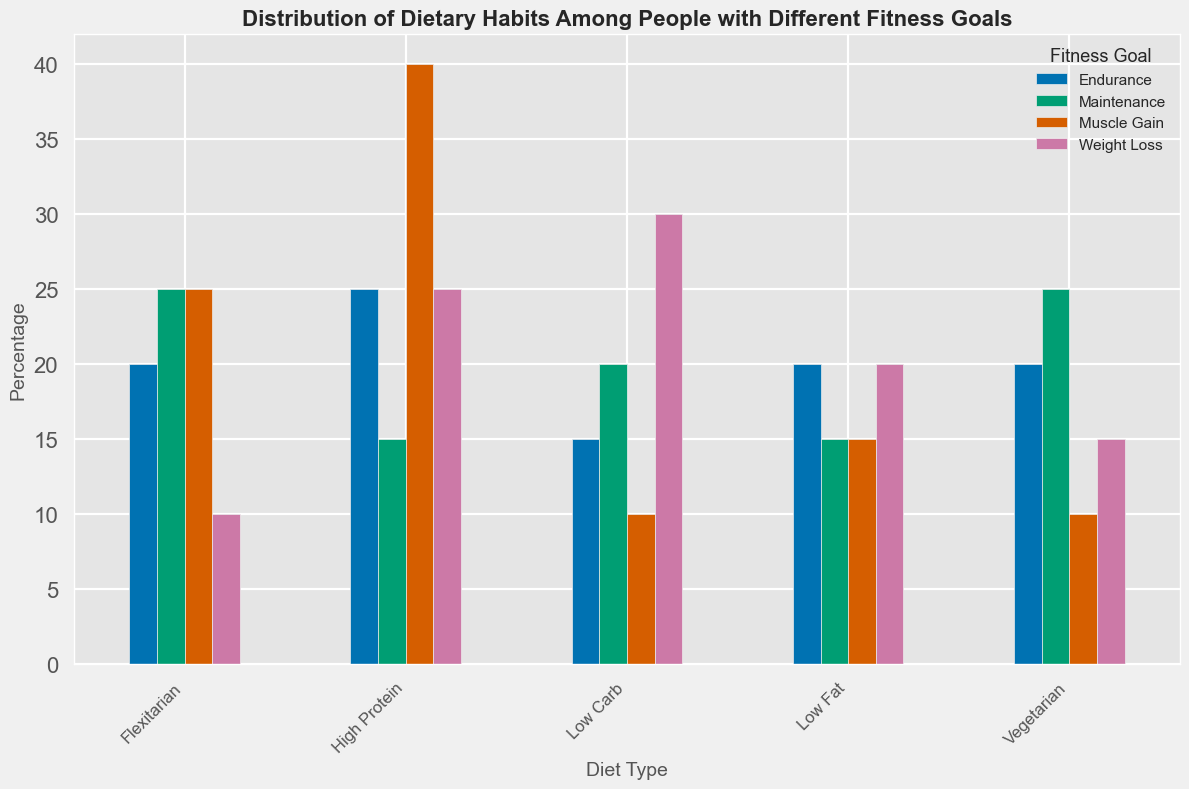What is the most common diet type among people aiming for muscle gain? By examining the height of the bars for each diet type under the "Muscle Gain" category, the "High Protein" bar is the tallest.
Answer: High Protein Which fitness goal has the highest proportion of people following a low-carb diet? Check the heights of the "Low Carb" bars for each fitness goal. The "Weight Loss" bar is the tallest.
Answer: Weight Loss How does the percentage of people following a vegetarian diet for muscle gain compare to those for weight loss? Compare the heights of the "Vegetarian" bars for "Muscle Gain" and "Weight Loss". The bar for "Weight Loss" is taller (15% vs. 10%).
Answer: Weight Loss has a higher percentage What is the average percentage of people following a low-fat diet across all fitness goals? Sum the percentages for "Low Fat" across all fitness goals (20% + 15% + 20% + 15%) = 70%, then divide by 4 (70/4).
Answer: 17.5% For which fitness goal is the Flexitarian diet as popular as the most common diet type for that goal? Check the bars for each goal and identify the most common diet. Compare this to the Flexitarian bar to see where they match. For "Maintenance", Flexitarian (25%) is equal to Vegetarian (25%), which is the most common.
Answer: Maintenance Among the "High Protein" diet followers, which fitness goal has the lowest percentage? Examine the bars for "High Protein" and identify the shortest one. It's "Maintenance" (15%).
Answer: Maintenance What is the combined percentage of people following either a low-carb or high-protein diet for weight loss? Add the percentages for "Low Carb" (30%) and "High Protein" (25%) for "Weight Loss". The total is 30 + 25 = 55%.
Answer: 55% Which diet type shows an equal distribution (percentages) among all fitness goals? Compare the bars horizontally for each diet type. The "Flexitarian" diet has bars of the same height (20%) across all fitness goals.
Answer: Flexitarian What is the difference in percentage between people following a high-protein diet for muscle gain and those for endurance? Subtract the percentage of "Endurance" (25%) from "Muscle Gain" (40%) for "High Protein". 40-25=15%.
Answer: 15% Which diet type is least popular for both weight loss and muscle gain combined? Compare combined percentages of all diet types for "Weight Loss" and "Muscle Gain". "Vegetarian" has 15% (Weight Loss) + 10% (Muscle Gain) = 25%, the lowest total.
Answer: Vegetarian 